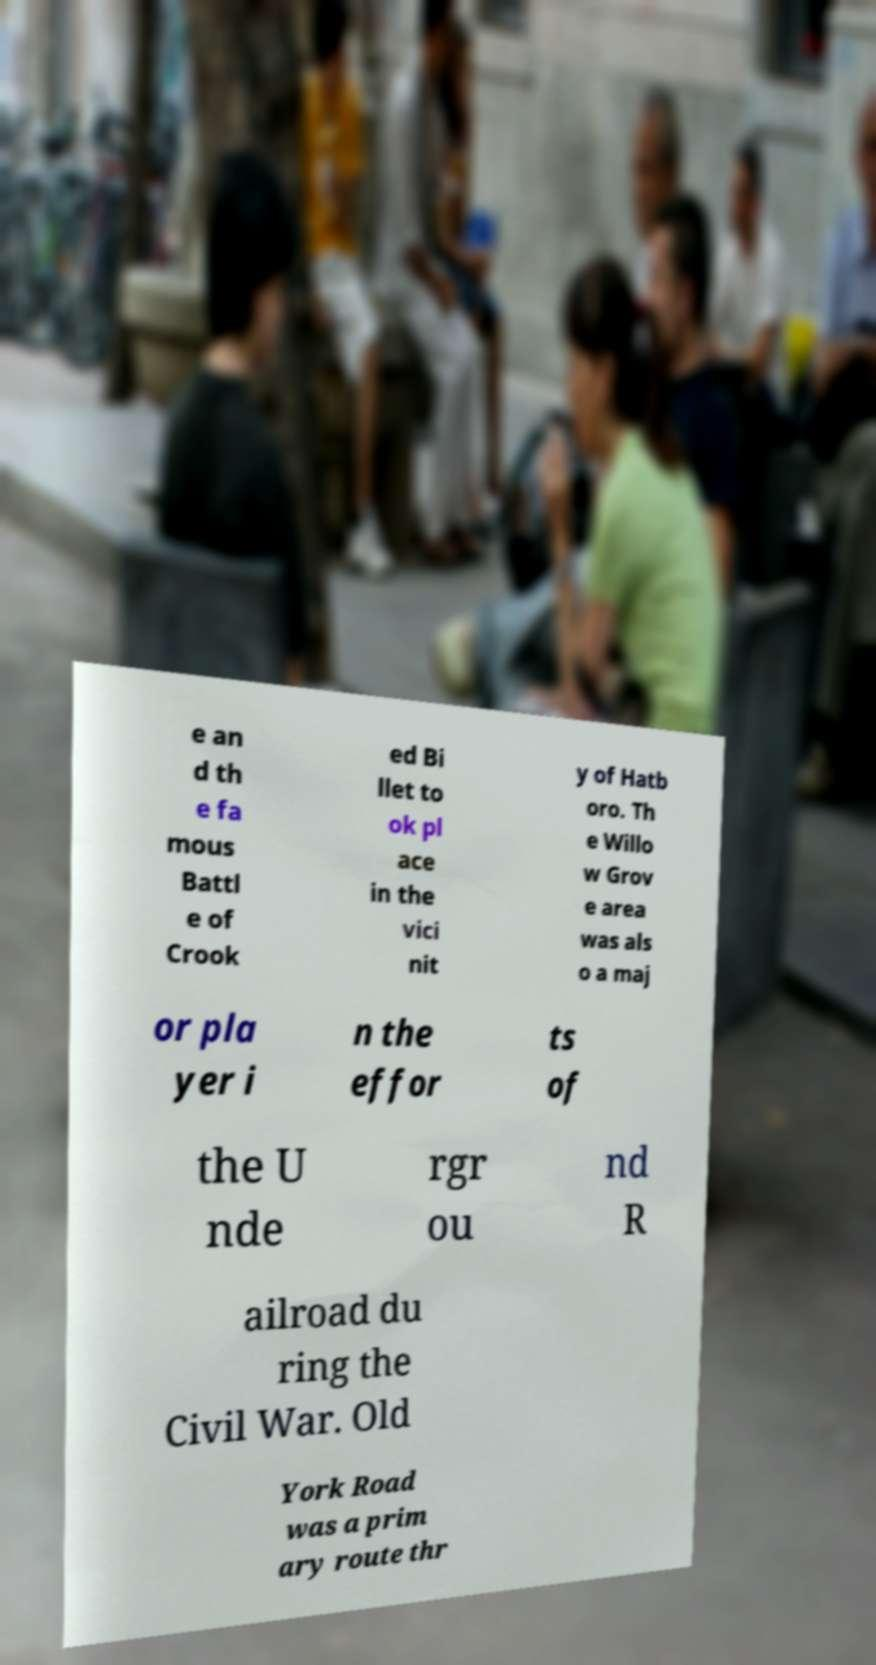Please read and relay the text visible in this image. What does it say? e an d th e fa mous Battl e of Crook ed Bi llet to ok pl ace in the vici nit y of Hatb oro. Th e Willo w Grov e area was als o a maj or pla yer i n the effor ts of the U nde rgr ou nd R ailroad du ring the Civil War. Old York Road was a prim ary route thr 